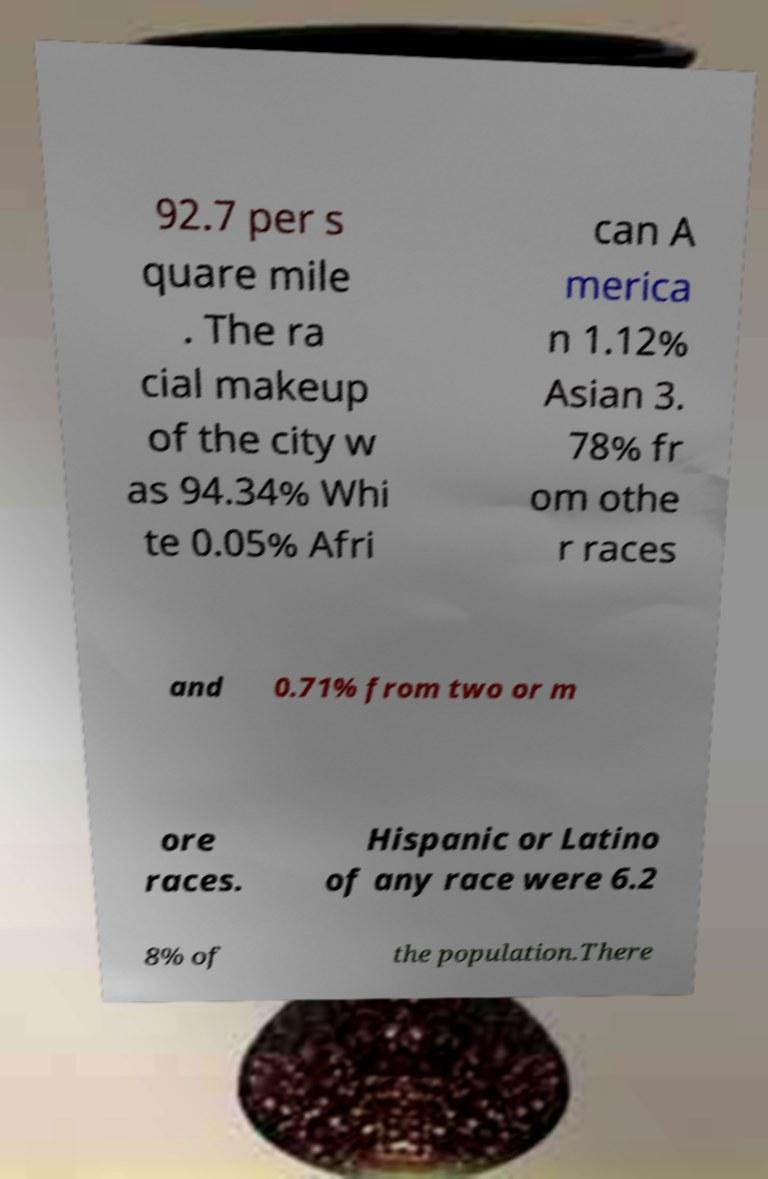Could you extract and type out the text from this image? 92.7 per s quare mile . The ra cial makeup of the city w as 94.34% Whi te 0.05% Afri can A merica n 1.12% Asian 3. 78% fr om othe r races and 0.71% from two or m ore races. Hispanic or Latino of any race were 6.2 8% of the population.There 